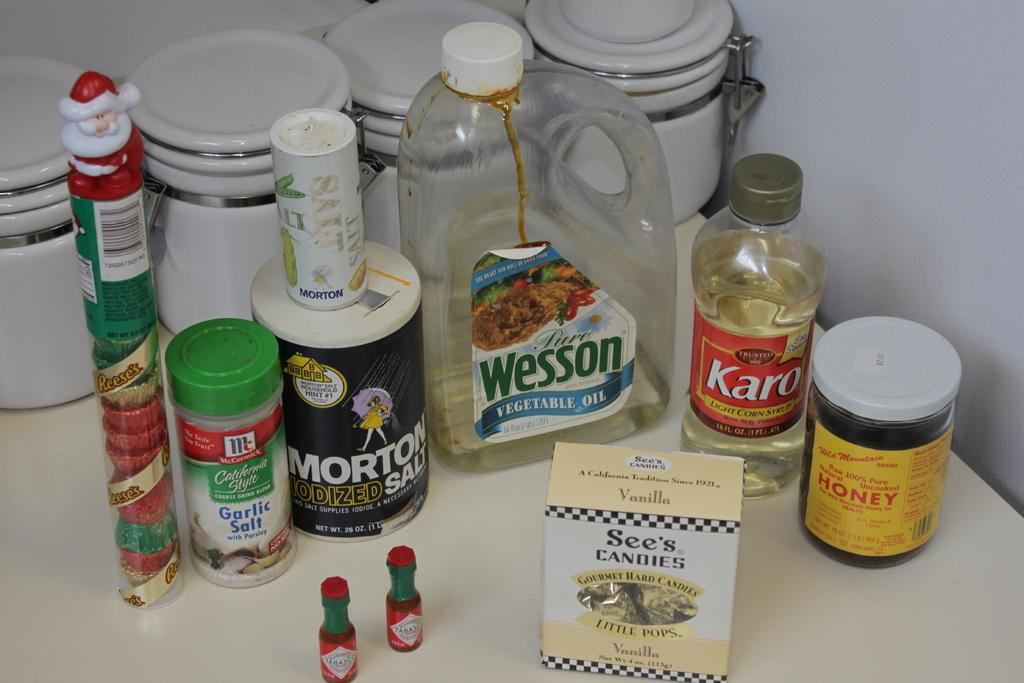<image>
Offer a succinct explanation of the picture presented. ingredients on a kitchen counter include Wesson Oil 